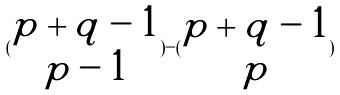Convert formula to latex. <formula><loc_0><loc_0><loc_500><loc_500>( \begin{matrix} p + q - 1 \\ p - 1 \end{matrix} ) - ( \begin{matrix} p + q - 1 \\ p \end{matrix} )</formula> 